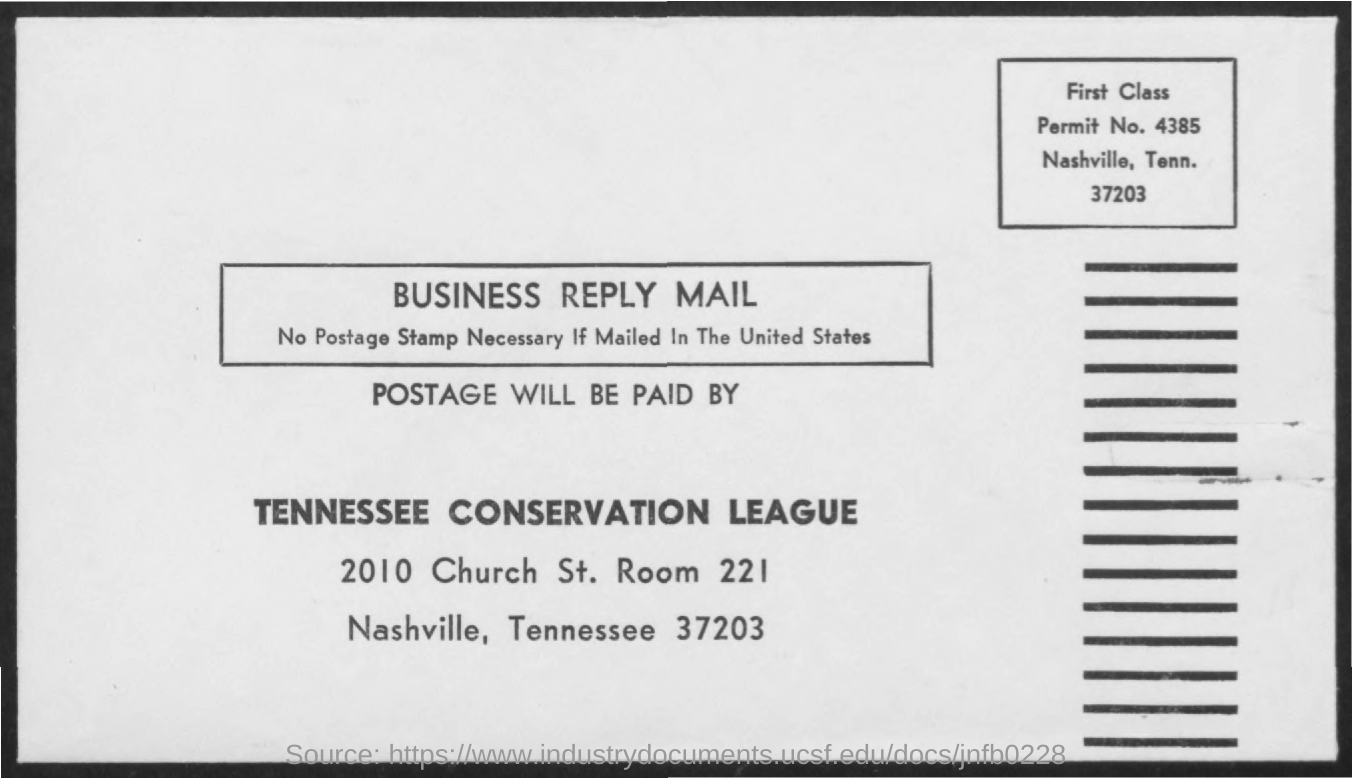Point out several critical features in this image. The name of the league is the Tennessee Conservation League. The permit number mentioned is 4385. The room number mentioned in the text is 221.. The Tennessee Conservation League will pay for the postage. 